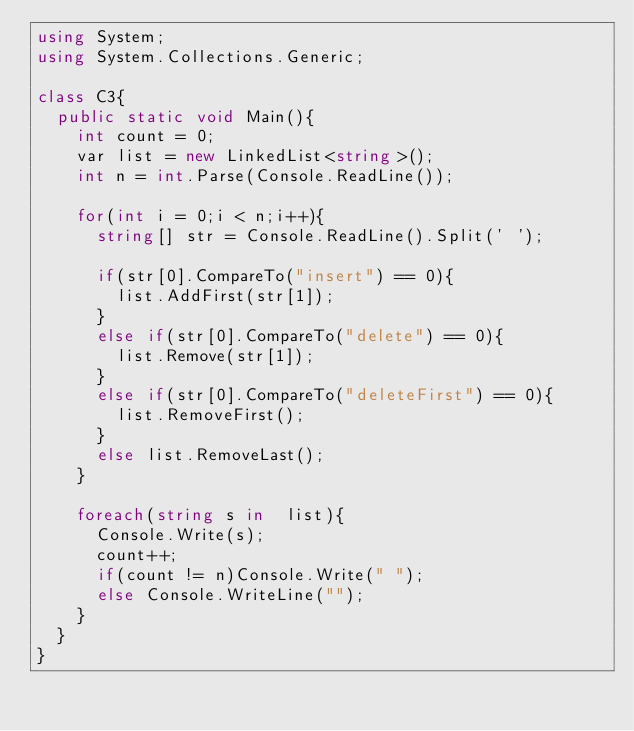Convert code to text. <code><loc_0><loc_0><loc_500><loc_500><_C#_>using System;
using System.Collections.Generic;

class C3{
  public static void Main(){
    int count = 0;
    var list = new LinkedList<string>();
    int n = int.Parse(Console.ReadLine());

    for(int i = 0;i < n;i++){
      string[] str = Console.ReadLine().Split(' ');

      if(str[0].CompareTo("insert") == 0){
        list.AddFirst(str[1]);
      }
      else if(str[0].CompareTo("delete") == 0){
        list.Remove(str[1]);
      }
      else if(str[0].CompareTo("deleteFirst") == 0){
        list.RemoveFirst();
      }
      else list.RemoveLast();
    }

    foreach(string s in  list){
      Console.Write(s);
      count++;
      if(count != n)Console.Write(" ");
      else Console.WriteLine("");
    }
  }
}

</code> 